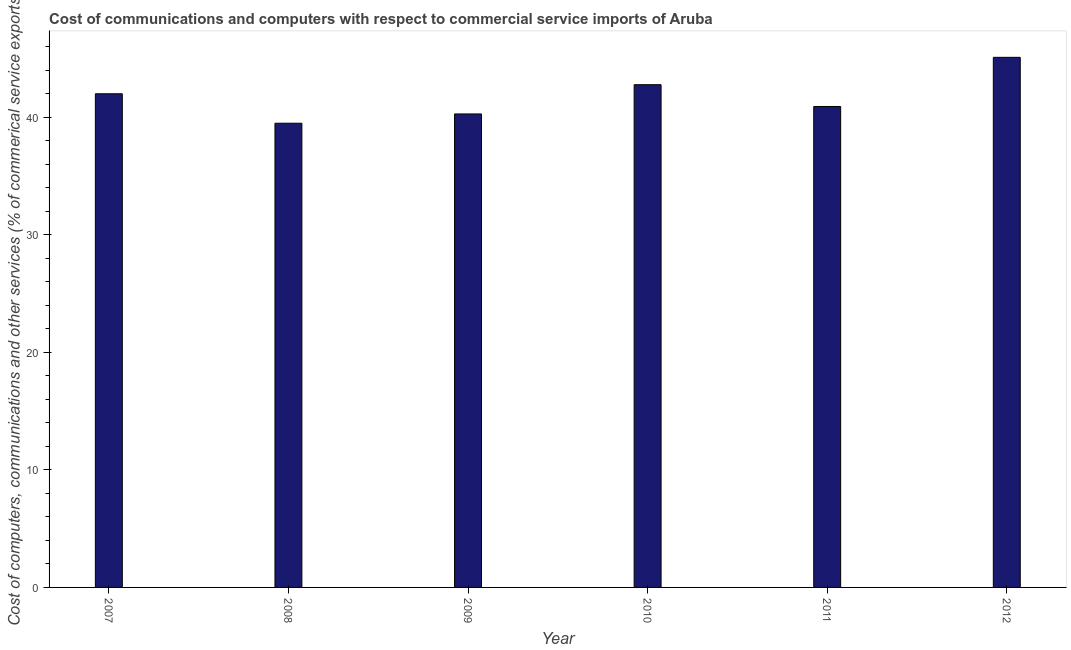Does the graph contain any zero values?
Ensure brevity in your answer.  No. What is the title of the graph?
Make the answer very short. Cost of communications and computers with respect to commercial service imports of Aruba. What is the label or title of the X-axis?
Ensure brevity in your answer.  Year. What is the label or title of the Y-axis?
Keep it short and to the point. Cost of computers, communications and other services (% of commerical service exports). What is the cost of communications in 2010?
Your answer should be compact. 42.79. Across all years, what is the maximum  computer and other services?
Provide a succinct answer. 45.12. Across all years, what is the minimum  computer and other services?
Your answer should be very brief. 39.51. What is the sum of the cost of communications?
Offer a terse response. 250.66. What is the difference between the  computer and other services in 2011 and 2012?
Offer a terse response. -4.18. What is the average cost of communications per year?
Offer a very short reply. 41.78. What is the median  computer and other services?
Provide a short and direct response. 41.47. In how many years, is the  computer and other services greater than 38 %?
Your answer should be compact. 6. What is the ratio of the  computer and other services in 2008 to that in 2009?
Offer a very short reply. 0.98. Is the cost of communications in 2007 less than that in 2011?
Make the answer very short. No. What is the difference between the highest and the second highest  computer and other services?
Keep it short and to the point. 2.33. Is the sum of the cost of communications in 2007 and 2008 greater than the maximum cost of communications across all years?
Make the answer very short. Yes. What is the difference between the highest and the lowest cost of communications?
Offer a very short reply. 5.61. In how many years, is the  computer and other services greater than the average  computer and other services taken over all years?
Provide a short and direct response. 3. How many bars are there?
Provide a short and direct response. 6. Are all the bars in the graph horizontal?
Make the answer very short. No. How many years are there in the graph?
Provide a short and direct response. 6. What is the Cost of computers, communications and other services (% of commerical service exports) in 2007?
Your response must be concise. 42.01. What is the Cost of computers, communications and other services (% of commerical service exports) of 2008?
Make the answer very short. 39.51. What is the Cost of computers, communications and other services (% of commerical service exports) in 2009?
Offer a terse response. 40.3. What is the Cost of computers, communications and other services (% of commerical service exports) in 2010?
Your response must be concise. 42.79. What is the Cost of computers, communications and other services (% of commerical service exports) in 2011?
Ensure brevity in your answer.  40.93. What is the Cost of computers, communications and other services (% of commerical service exports) of 2012?
Your answer should be compact. 45.12. What is the difference between the Cost of computers, communications and other services (% of commerical service exports) in 2007 and 2008?
Ensure brevity in your answer.  2.51. What is the difference between the Cost of computers, communications and other services (% of commerical service exports) in 2007 and 2009?
Your answer should be compact. 1.72. What is the difference between the Cost of computers, communications and other services (% of commerical service exports) in 2007 and 2010?
Provide a short and direct response. -0.77. What is the difference between the Cost of computers, communications and other services (% of commerical service exports) in 2007 and 2011?
Offer a terse response. 1.08. What is the difference between the Cost of computers, communications and other services (% of commerical service exports) in 2007 and 2012?
Offer a very short reply. -3.1. What is the difference between the Cost of computers, communications and other services (% of commerical service exports) in 2008 and 2009?
Ensure brevity in your answer.  -0.79. What is the difference between the Cost of computers, communications and other services (% of commerical service exports) in 2008 and 2010?
Your response must be concise. -3.28. What is the difference between the Cost of computers, communications and other services (% of commerical service exports) in 2008 and 2011?
Your answer should be very brief. -1.42. What is the difference between the Cost of computers, communications and other services (% of commerical service exports) in 2008 and 2012?
Make the answer very short. -5.61. What is the difference between the Cost of computers, communications and other services (% of commerical service exports) in 2009 and 2010?
Offer a terse response. -2.49. What is the difference between the Cost of computers, communications and other services (% of commerical service exports) in 2009 and 2011?
Keep it short and to the point. -0.64. What is the difference between the Cost of computers, communications and other services (% of commerical service exports) in 2009 and 2012?
Offer a terse response. -4.82. What is the difference between the Cost of computers, communications and other services (% of commerical service exports) in 2010 and 2011?
Your answer should be very brief. 1.86. What is the difference between the Cost of computers, communications and other services (% of commerical service exports) in 2010 and 2012?
Give a very brief answer. -2.33. What is the difference between the Cost of computers, communications and other services (% of commerical service exports) in 2011 and 2012?
Make the answer very short. -4.18. What is the ratio of the Cost of computers, communications and other services (% of commerical service exports) in 2007 to that in 2008?
Offer a very short reply. 1.06. What is the ratio of the Cost of computers, communications and other services (% of commerical service exports) in 2007 to that in 2009?
Offer a very short reply. 1.04. What is the ratio of the Cost of computers, communications and other services (% of commerical service exports) in 2007 to that in 2010?
Offer a terse response. 0.98. What is the ratio of the Cost of computers, communications and other services (% of commerical service exports) in 2007 to that in 2011?
Make the answer very short. 1.03. What is the ratio of the Cost of computers, communications and other services (% of commerical service exports) in 2008 to that in 2010?
Give a very brief answer. 0.92. What is the ratio of the Cost of computers, communications and other services (% of commerical service exports) in 2008 to that in 2012?
Keep it short and to the point. 0.88. What is the ratio of the Cost of computers, communications and other services (% of commerical service exports) in 2009 to that in 2010?
Offer a very short reply. 0.94. What is the ratio of the Cost of computers, communications and other services (% of commerical service exports) in 2009 to that in 2011?
Give a very brief answer. 0.98. What is the ratio of the Cost of computers, communications and other services (% of commerical service exports) in 2009 to that in 2012?
Keep it short and to the point. 0.89. What is the ratio of the Cost of computers, communications and other services (% of commerical service exports) in 2010 to that in 2011?
Your answer should be very brief. 1.04. What is the ratio of the Cost of computers, communications and other services (% of commerical service exports) in 2010 to that in 2012?
Offer a terse response. 0.95. What is the ratio of the Cost of computers, communications and other services (% of commerical service exports) in 2011 to that in 2012?
Ensure brevity in your answer.  0.91. 